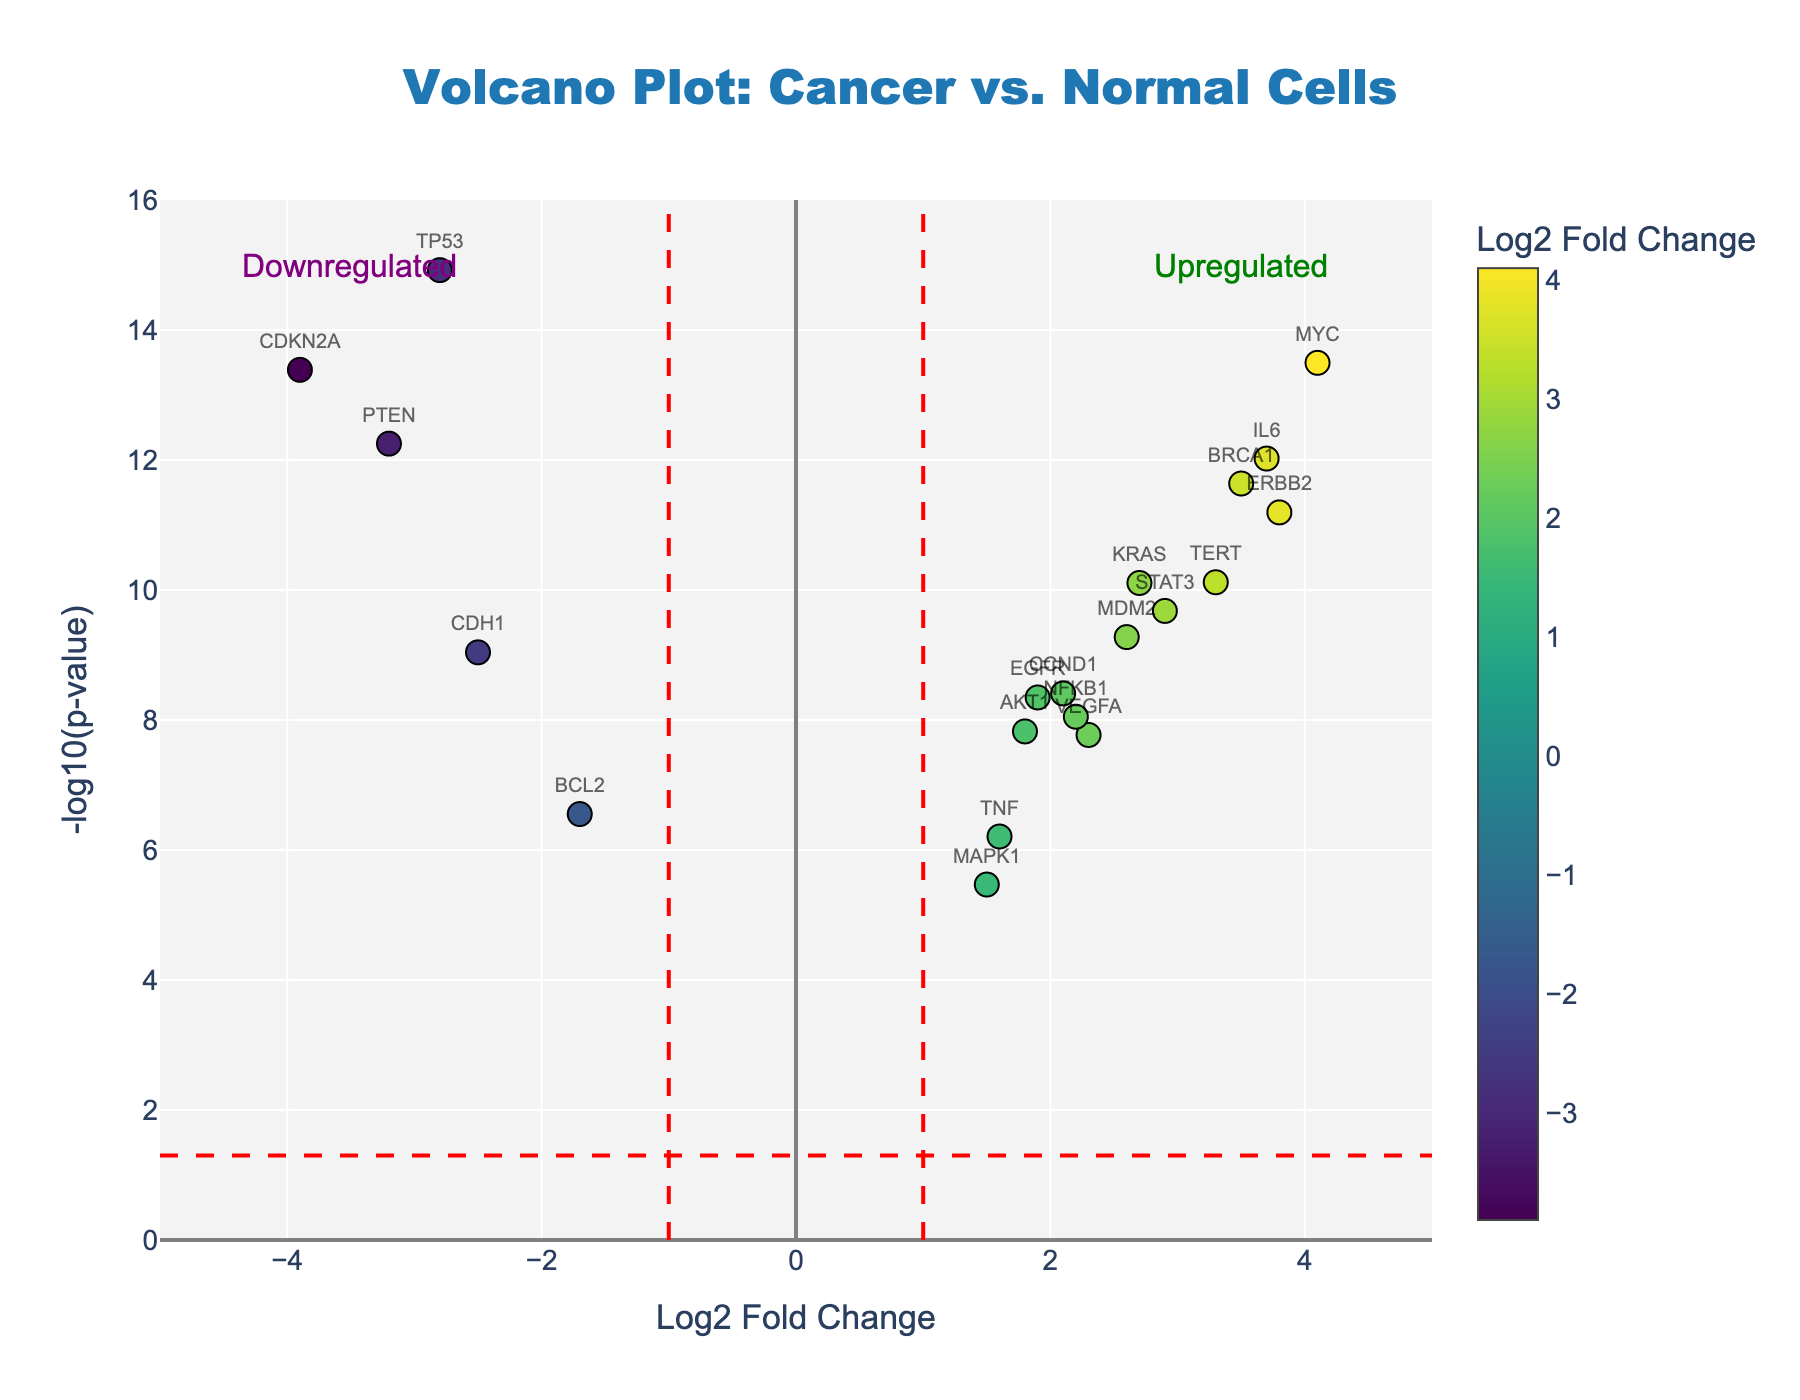What is the title of the plot? The title is written at the top center of the plot. It reads "Volcano Plot: Cancer vs. Normal Cells".
Answer: Volcano Plot: Cancer vs. Normal Cells What are the labels for the axes? The x-axis title is "Log2 Fold Change" and the y-axis title is "-log10(p-value)".
Answer: Log2 Fold Change; -log10(p-value) How many genes are upregulated with a Log2 Fold Change greater than 2? To answer this, count the data points on the plot with Log2 Fold Change values greater than 2.
Answer: 8 Which gene has the highest fold change? By looking at the plot, identify the data point furthest right on the x-axis. The highest Log2 Fold Change is 4.1 for the gene MYC.
Answer: MYC Which genes have a p-value less than 1e-12? The p-value is represented on the y-axis as -log10(p-value). A p-value less than 1e-12 corresponds to values above 12 on the y-axis. The genes with these values are TP53, BRCA1, MYC, PTEN, CDKN2A, and IL6.
Answer: TP53, BRCA1, MYC, PTEN, CDKN2A, IL6 Which gene is closest to the threshold line for a p-value of 0.05? The threshold line for a p-value of 0.05 is represented by a horizontal dashed line in the plot. The data point closest to this line is MAPK1.
Answer: MAPK1 How many genes are significantly downregulated? Downregulated genes have a negative Log2 Fold Change and a p-value below the -log10(0.05) threshold line, hence shown above the horizontal dashed line on the left side. There are 5 such genes: TP53, PTEN, CDH1, BCL2, and CDKN2A.
Answer: 5 What is the Log2 Fold Change and p-value of the KRAS gene? Locate KRAS data point on the plot and refer to its values on the x and y axes. KRAS has a Log2 Fold Change of 2.7 and p-value of 7.8e-11.
Answer: 2.7; 7.8e-11 Which gene has the lowest p-value and is upregulated? The lowest p-value corresponds to the highest -log10(p-value) on the y-axis. For upregulated genes (positive Log2 Fold Change), MYC has the highest y-axis value and is upregulated.
Answer: MYC 